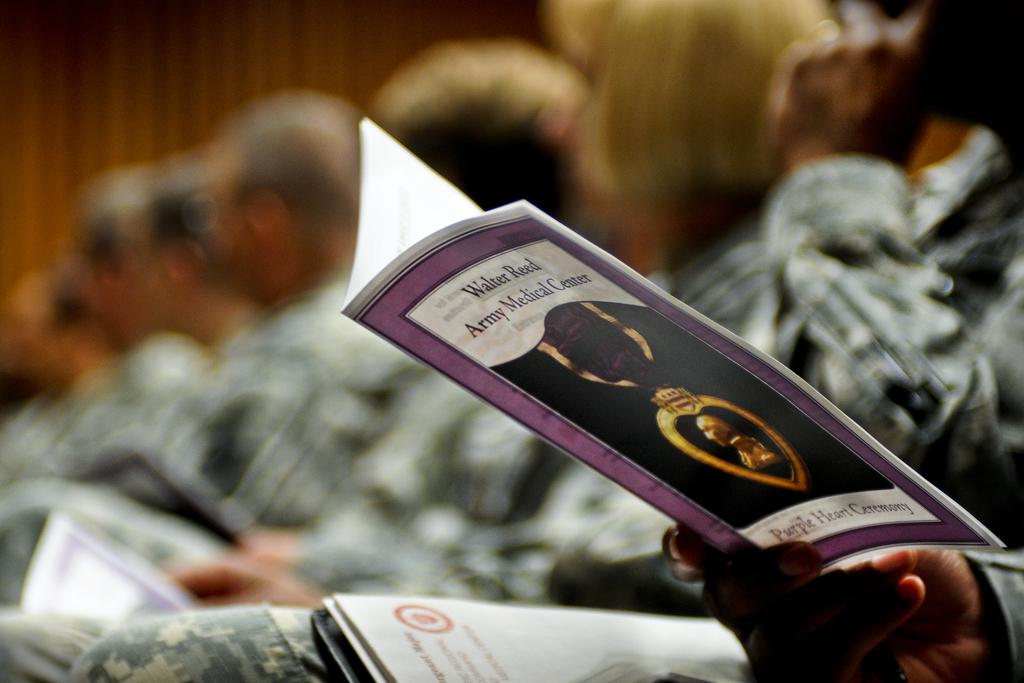Provide a one-sentence caption for the provided image. A close up view of a program from the Walter Reed Army Medical Center. 